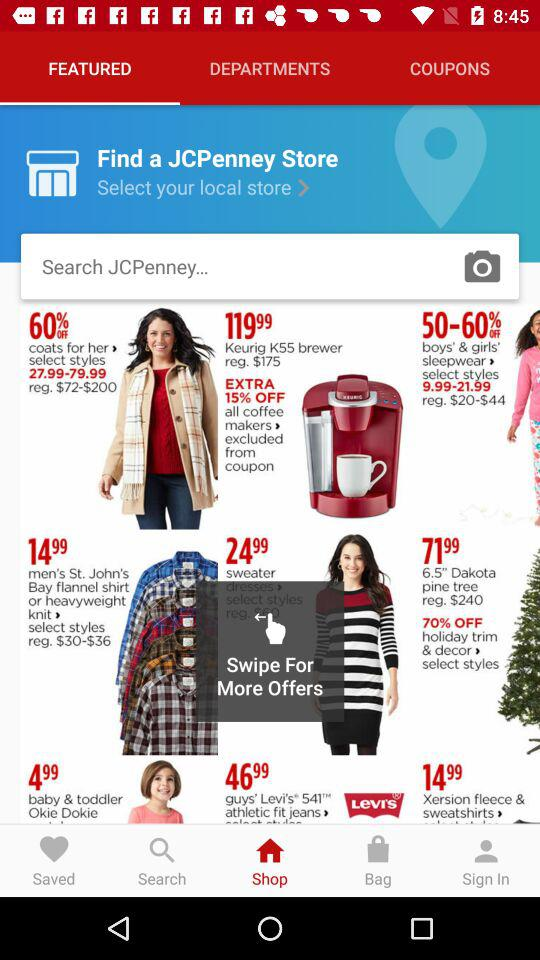What is the name of the store? The store name is JCPenney Store. 